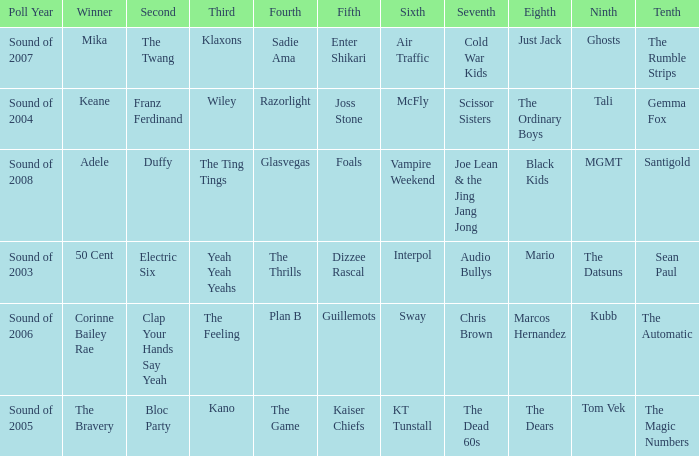When the 8th is Marcos Hernandez who was the 6th? Sway. Parse the full table. {'header': ['Poll Year', 'Winner', 'Second', 'Third', 'Fourth', 'Fifth', 'Sixth', 'Seventh', 'Eighth', 'Ninth', 'Tenth'], 'rows': [['Sound of 2007', 'Mika', 'The Twang', 'Klaxons', 'Sadie Ama', 'Enter Shikari', 'Air Traffic', 'Cold War Kids', 'Just Jack', 'Ghosts', 'The Rumble Strips'], ['Sound of 2004', 'Keane', 'Franz Ferdinand', 'Wiley', 'Razorlight', 'Joss Stone', 'McFly', 'Scissor Sisters', 'The Ordinary Boys', 'Tali', 'Gemma Fox'], ['Sound of 2008', 'Adele', 'Duffy', 'The Ting Tings', 'Glasvegas', 'Foals', 'Vampire Weekend', 'Joe Lean & the Jing Jang Jong', 'Black Kids', 'MGMT', 'Santigold'], ['Sound of 2003', '50 Cent', 'Electric Six', 'Yeah Yeah Yeahs', 'The Thrills', 'Dizzee Rascal', 'Interpol', 'Audio Bullys', 'Mario', 'The Datsuns', 'Sean Paul'], ['Sound of 2006', 'Corinne Bailey Rae', 'Clap Your Hands Say Yeah', 'The Feeling', 'Plan B', 'Guillemots', 'Sway', 'Chris Brown', 'Marcos Hernandez', 'Kubb', 'The Automatic'], ['Sound of 2005', 'The Bravery', 'Bloc Party', 'Kano', 'The Game', 'Kaiser Chiefs', 'KT Tunstall', 'The Dead 60s', 'The Dears', 'Tom Vek', 'The Magic Numbers']]} 